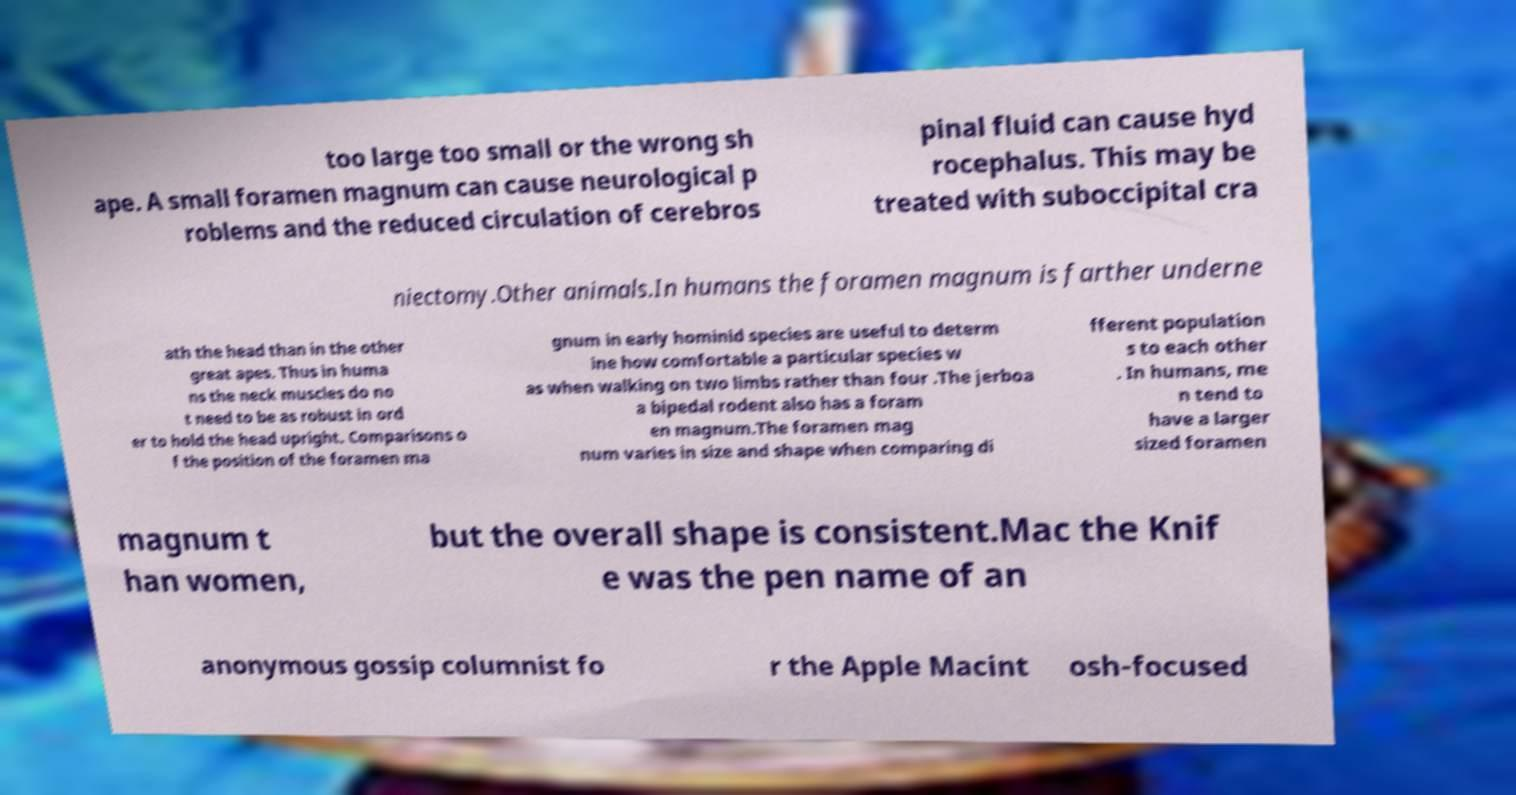Can you accurately transcribe the text from the provided image for me? too large too small or the wrong sh ape. A small foramen magnum can cause neurological p roblems and the reduced circulation of cerebros pinal fluid can cause hyd rocephalus. This may be treated with suboccipital cra niectomy.Other animals.In humans the foramen magnum is farther underne ath the head than in the other great apes. Thus in huma ns the neck muscles do no t need to be as robust in ord er to hold the head upright. Comparisons o f the position of the foramen ma gnum in early hominid species are useful to determ ine how comfortable a particular species w as when walking on two limbs rather than four .The jerboa a bipedal rodent also has a foram en magnum.The foramen mag num varies in size and shape when comparing di fferent population s to each other . In humans, me n tend to have a larger sized foramen magnum t han women, but the overall shape is consistent.Mac the Knif e was the pen name of an anonymous gossip columnist fo r the Apple Macint osh-focused 